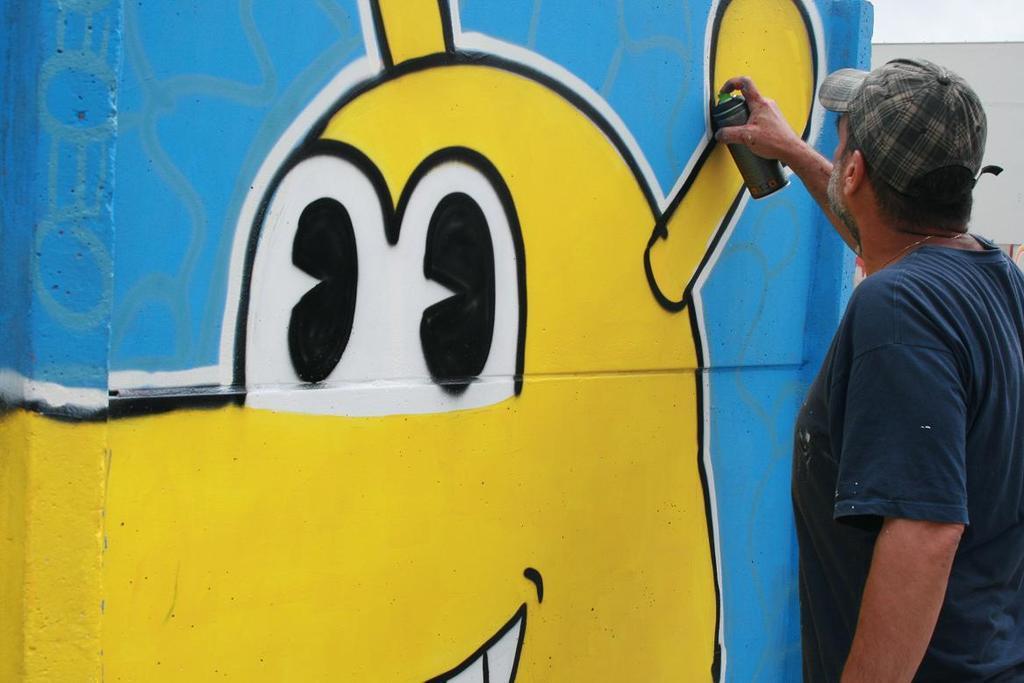Please provide a concise description of this image. In this image we can see a person wearing the cap and standing and also holding the spray bottle. We can also see the wall with the graffiti. 